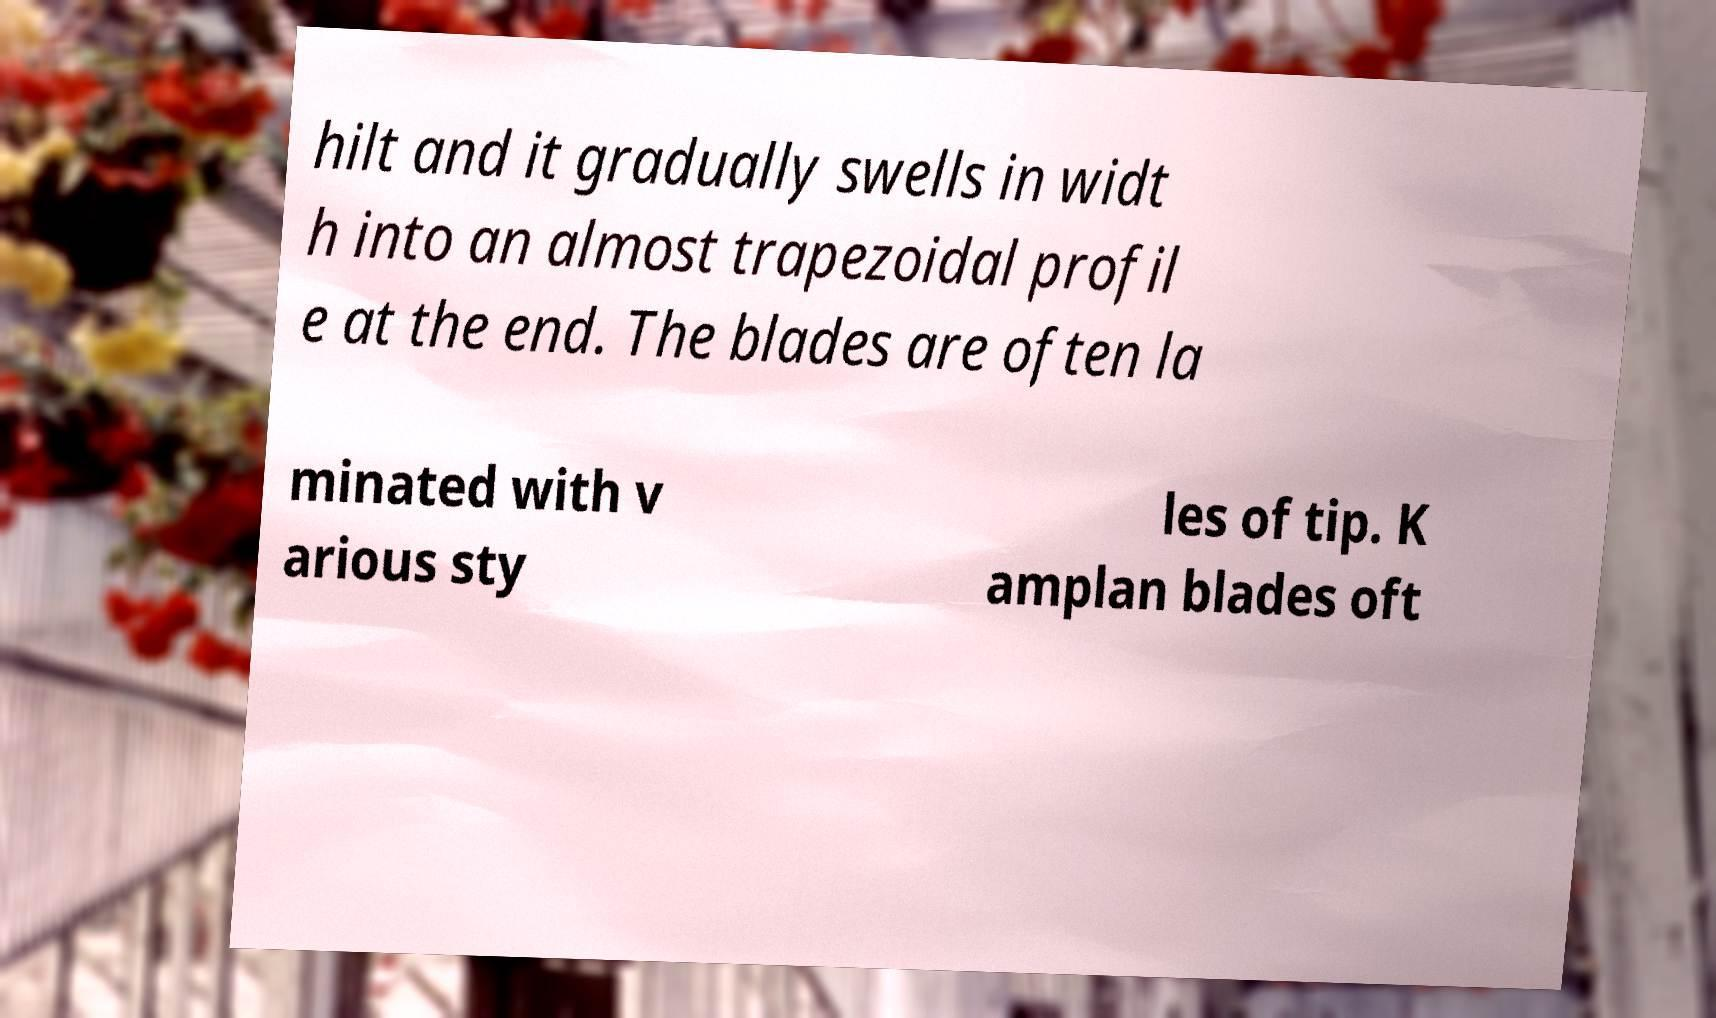Please read and relay the text visible in this image. What does it say? hilt and it gradually swells in widt h into an almost trapezoidal profil e at the end. The blades are often la minated with v arious sty les of tip. K amplan blades oft 